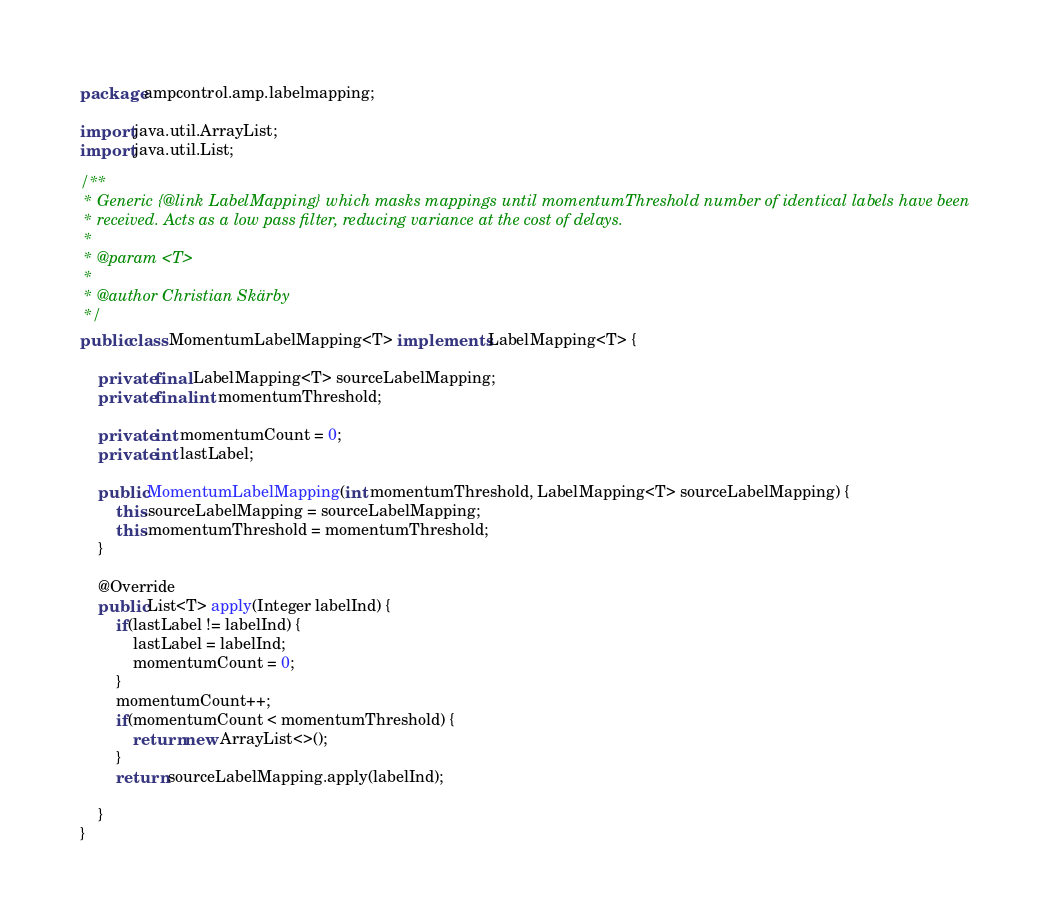Convert code to text. <code><loc_0><loc_0><loc_500><loc_500><_Java_>package ampcontrol.amp.labelmapping;

import java.util.ArrayList;
import java.util.List;

/**
 * Generic {@link LabelMapping} which masks mappings until momentumThreshold number of identical labels have been
 * received. Acts as a low pass filter, reducing variance at the cost of delays.
 *
 * @param <T>
 *
 * @author Christian Skärby
 */
public class MomentumLabelMapping<T> implements LabelMapping<T> {

    private final LabelMapping<T> sourceLabelMapping;
    private final int momentumThreshold;

    private int momentumCount = 0;
    private int lastLabel;

    public MomentumLabelMapping(int momentumThreshold, LabelMapping<T> sourceLabelMapping) {
        this.sourceLabelMapping = sourceLabelMapping;
        this.momentumThreshold = momentumThreshold;
    }

    @Override
    public List<T> apply(Integer labelInd) {
        if(lastLabel != labelInd) {
            lastLabel = labelInd;
            momentumCount = 0;
        }
        momentumCount++;
        if(momentumCount < momentumThreshold) {
            return new ArrayList<>();
        }
        return sourceLabelMapping.apply(labelInd);

    }
}
</code> 